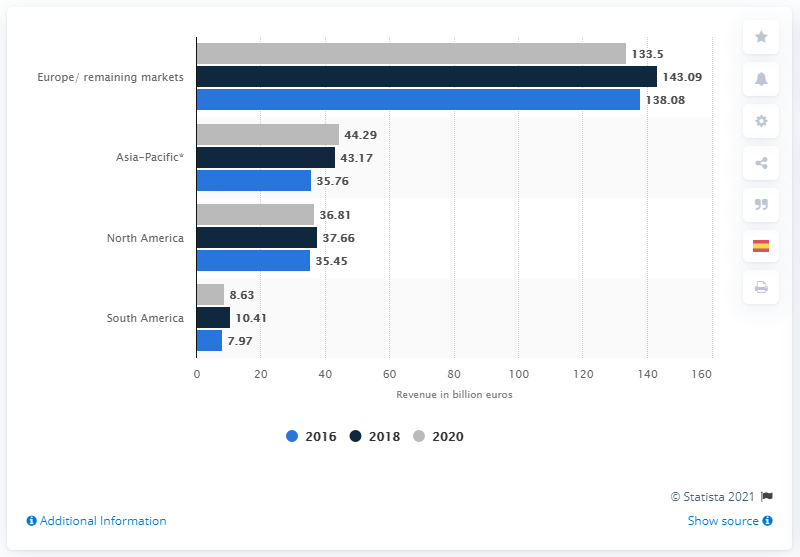Give some essential details in this illustration. In 2020, Volkswagen's revenue in North America was 36.81 billion U.S. dollars. 